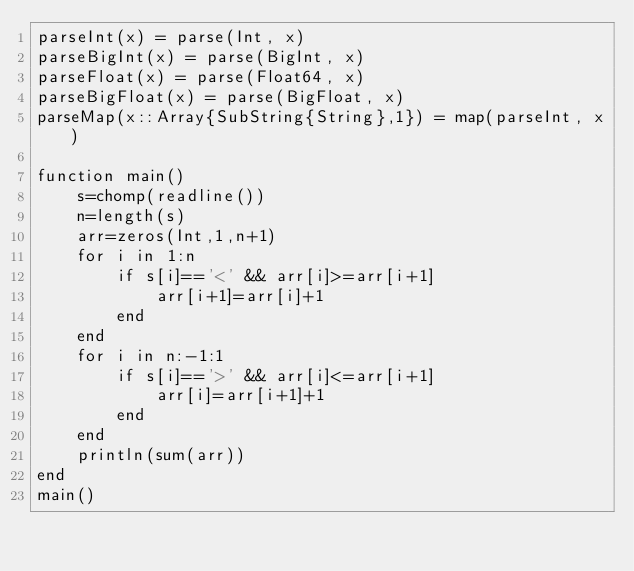<code> <loc_0><loc_0><loc_500><loc_500><_Julia_>parseInt(x) = parse(Int, x)
parseBigInt(x) = parse(BigInt, x)
parseFloat(x) = parse(Float64, x)
parseBigFloat(x) = parse(BigFloat, x)
parseMap(x::Array{SubString{String},1}) = map(parseInt, x)

function main()
    s=chomp(readline())
    n=length(s)
    arr=zeros(Int,1,n+1)
    for i in 1:n
        if s[i]=='<' && arr[i]>=arr[i+1]
            arr[i+1]=arr[i]+1
        end
    end
    for i in n:-1:1
        if s[i]=='>' && arr[i]<=arr[i+1]
            arr[i]=arr[i+1]+1
        end
    end
    println(sum(arr))
end
main()</code> 